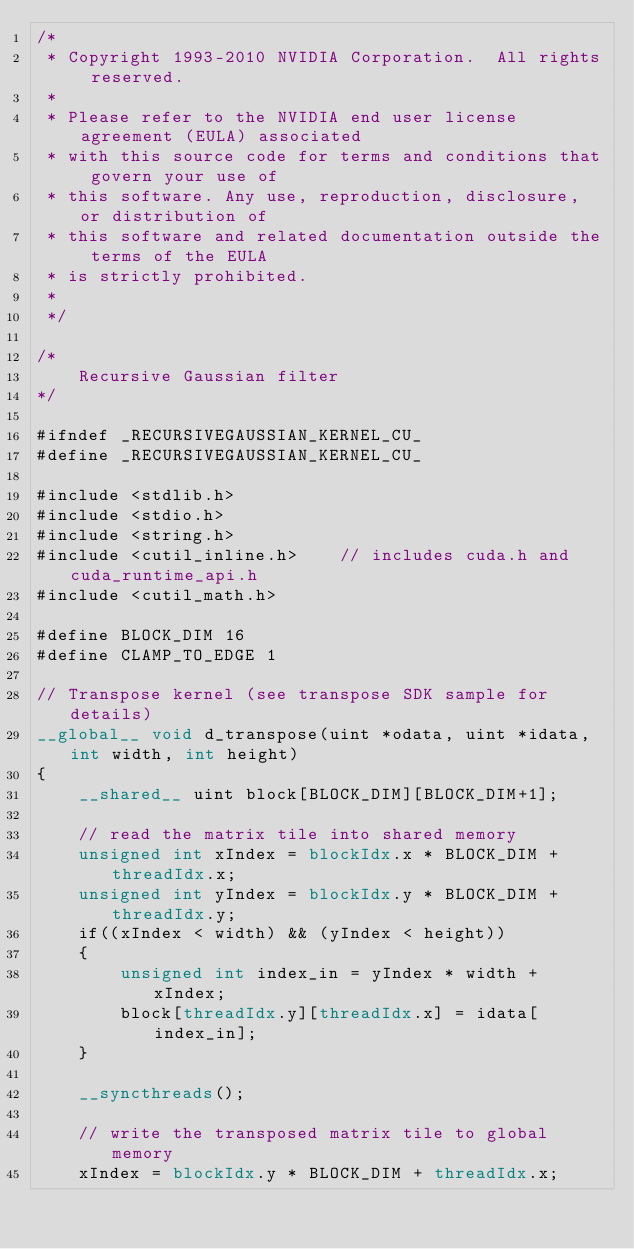<code> <loc_0><loc_0><loc_500><loc_500><_Cuda_>/*
 * Copyright 1993-2010 NVIDIA Corporation.  All rights reserved.
 *
 * Please refer to the NVIDIA end user license agreement (EULA) associated
 * with this source code for terms and conditions that govern your use of
 * this software. Any use, reproduction, disclosure, or distribution of
 * this software and related documentation outside the terms of the EULA
 * is strictly prohibited.
 *
 */

/*
    Recursive Gaussian filter
*/

#ifndef _RECURSIVEGAUSSIAN_KERNEL_CU_
#define _RECURSIVEGAUSSIAN_KERNEL_CU_

#include <stdlib.h>
#include <stdio.h>
#include <string.h>
#include <cutil_inline.h>    // includes cuda.h and cuda_runtime_api.h
#include <cutil_math.h>

#define BLOCK_DIM 16
#define CLAMP_TO_EDGE 1

// Transpose kernel (see transpose SDK sample for details)
__global__ void d_transpose(uint *odata, uint *idata, int width, int height)
{
    __shared__ uint block[BLOCK_DIM][BLOCK_DIM+1];
    
    // read the matrix tile into shared memory
    unsigned int xIndex = blockIdx.x * BLOCK_DIM + threadIdx.x;
    unsigned int yIndex = blockIdx.y * BLOCK_DIM + threadIdx.y;
    if((xIndex < width) && (yIndex < height))
    {
        unsigned int index_in = yIndex * width + xIndex;
        block[threadIdx.y][threadIdx.x] = idata[index_in];
    }

    __syncthreads();

    // write the transposed matrix tile to global memory
    xIndex = blockIdx.y * BLOCK_DIM + threadIdx.x;</code> 